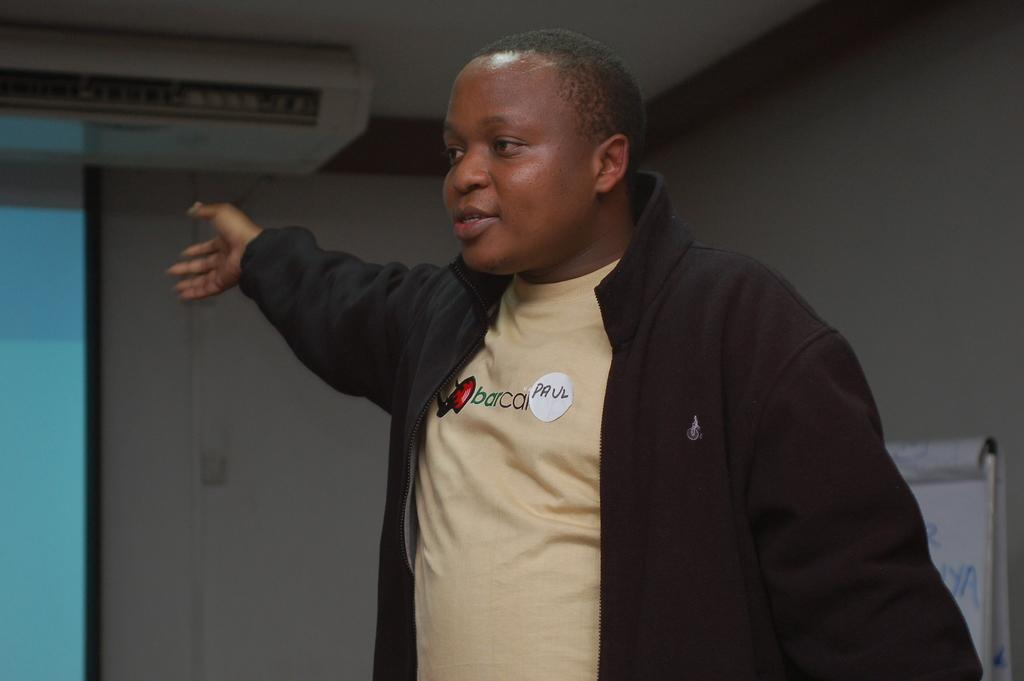What is the main subject of the image? There is a person in the image. Can you describe the person's clothing? The person is wearing a cream-colored T-shirt and a black-colored jacket. What is the person doing in the image? The person is raising their hands. What can be seen in the background of the image? There is an A.C., a wall, and a board in the background of the image. What title: What is the title of the book the person is holding in the image? There is no book visible in the image, so it is not possible to determine the title. 